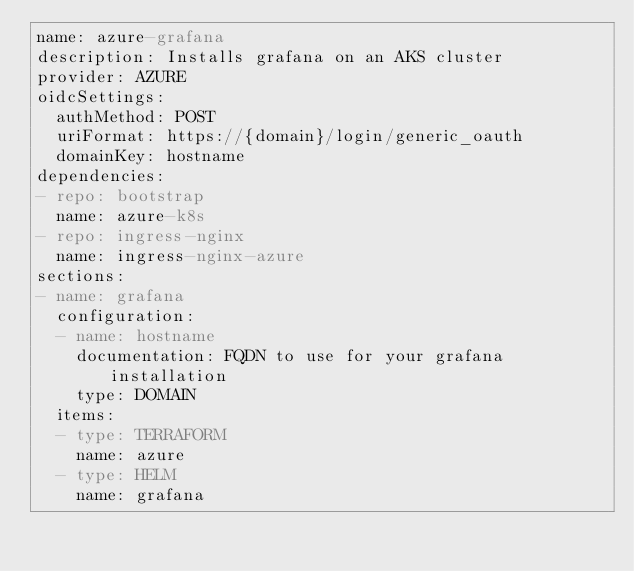<code> <loc_0><loc_0><loc_500><loc_500><_YAML_>name: azure-grafana
description: Installs grafana on an AKS cluster
provider: AZURE
oidcSettings:
  authMethod: POST
  uriFormat: https://{domain}/login/generic_oauth
  domainKey: hostname
dependencies:
- repo: bootstrap
  name: azure-k8s
- repo: ingress-nginx
  name: ingress-nginx-azure
sections:
- name: grafana
  configuration:
  - name: hostname
    documentation: FQDN to use for your grafana installation
    type: DOMAIN
  items:
  - type: TERRAFORM
    name: azure
  - type: HELM
    name: grafana
</code> 